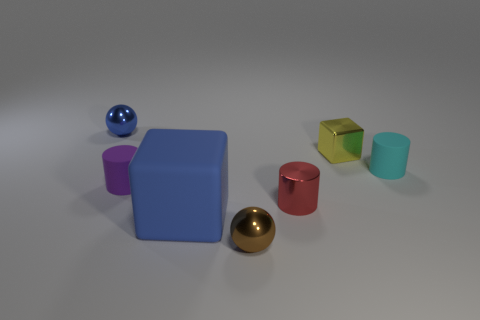Does the blue matte object have the same size as the shiny ball in front of the small cyan cylinder?
Your response must be concise. No. The thing that is in front of the tiny purple rubber cylinder and right of the small brown metal sphere is what color?
Your response must be concise. Red. What number of other things are the same shape as the cyan thing?
Offer a very short reply. 2. Is the color of the small rubber cylinder that is in front of the cyan cylinder the same as the shiny ball to the left of the tiny brown shiny object?
Your response must be concise. No. Does the cylinder that is right of the red shiny cylinder have the same size as the matte object that is on the left side of the big blue cube?
Make the answer very short. Yes. Is there anything else that has the same material as the big blue block?
Your answer should be compact. Yes. What material is the tiny ball that is on the right side of the tiny shiny ball that is left of the ball that is in front of the cyan object made of?
Ensure brevity in your answer.  Metal. Does the small cyan rubber thing have the same shape as the tiny blue object?
Provide a succinct answer. No. There is a red object that is the same shape as the cyan matte thing; what material is it?
Ensure brevity in your answer.  Metal. How many small shiny balls have the same color as the small metal cylinder?
Your answer should be very brief. 0. 